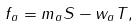Convert formula to latex. <formula><loc_0><loc_0><loc_500><loc_500>f _ { a } = m _ { a } S - w _ { a } T ,</formula> 